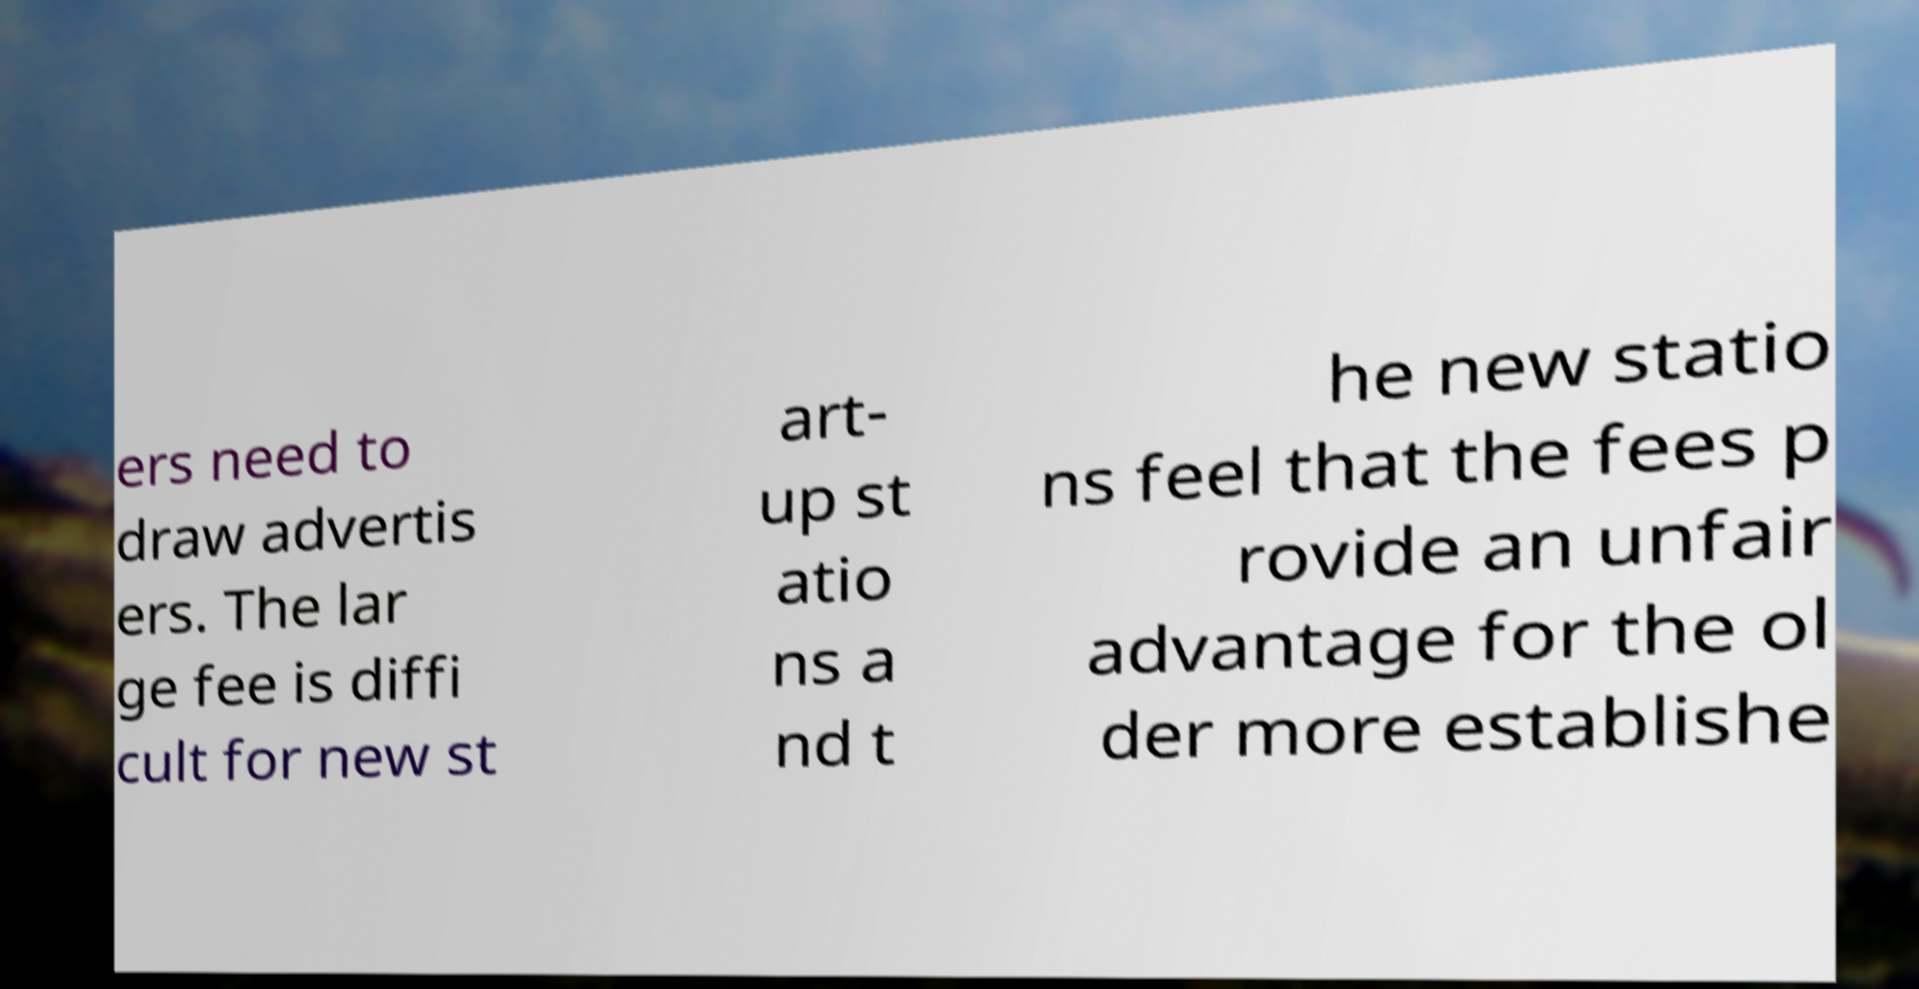Can you read and provide the text displayed in the image?This photo seems to have some interesting text. Can you extract and type it out for me? ers need to draw advertis ers. The lar ge fee is diffi cult for new st art- up st atio ns a nd t he new statio ns feel that the fees p rovide an unfair advantage for the ol der more establishe 